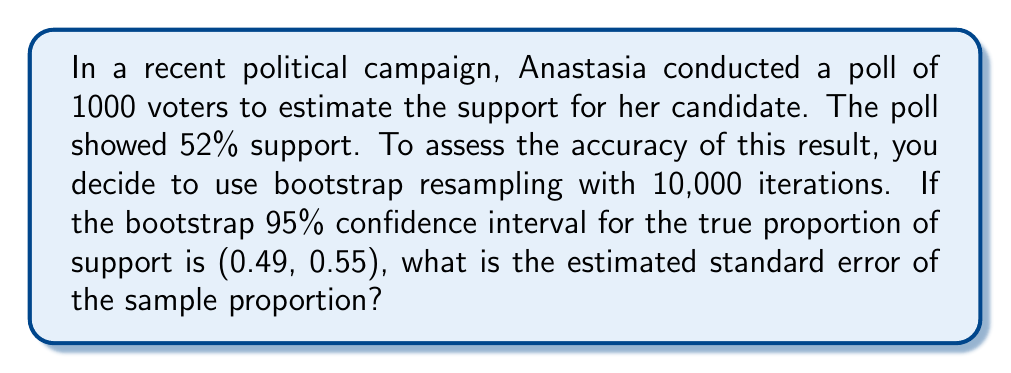What is the answer to this math problem? Let's approach this step-by-step:

1) The bootstrap method estimates the sampling distribution of a statistic by resampling with replacement from the original sample.

2) The 95% confidence interval is given as (0.49, 0.55). For a normal distribution, this interval is approximately ±1.96 standard errors from the mean.

3) Let $\hat{p}$ be the sample proportion (0.52) and $SE$ be the standard error we're trying to find.

4) The confidence interval can be expressed as:

   $$(\hat{p} - 1.96 \times SE, \hat{p} + 1.96 \times SE)$$

5) From the given interval:

   $$0.49 = 0.52 - 1.96 \times SE$$
   $$0.55 = 0.52 + 1.96 \times SE$$

6) Subtracting these equations:

   $$0.55 - 0.49 = (0.52 + 1.96 \times SE) - (0.52 - 1.96 \times SE)$$
   $$0.06 = 3.92 \times SE$$

7) Solving for $SE$:

   $$SE = \frac{0.06}{3.92} \approx 0.0153$$

Thus, the estimated standard error is approximately 0.0153 or 1.53%.
Answer: 0.0153 